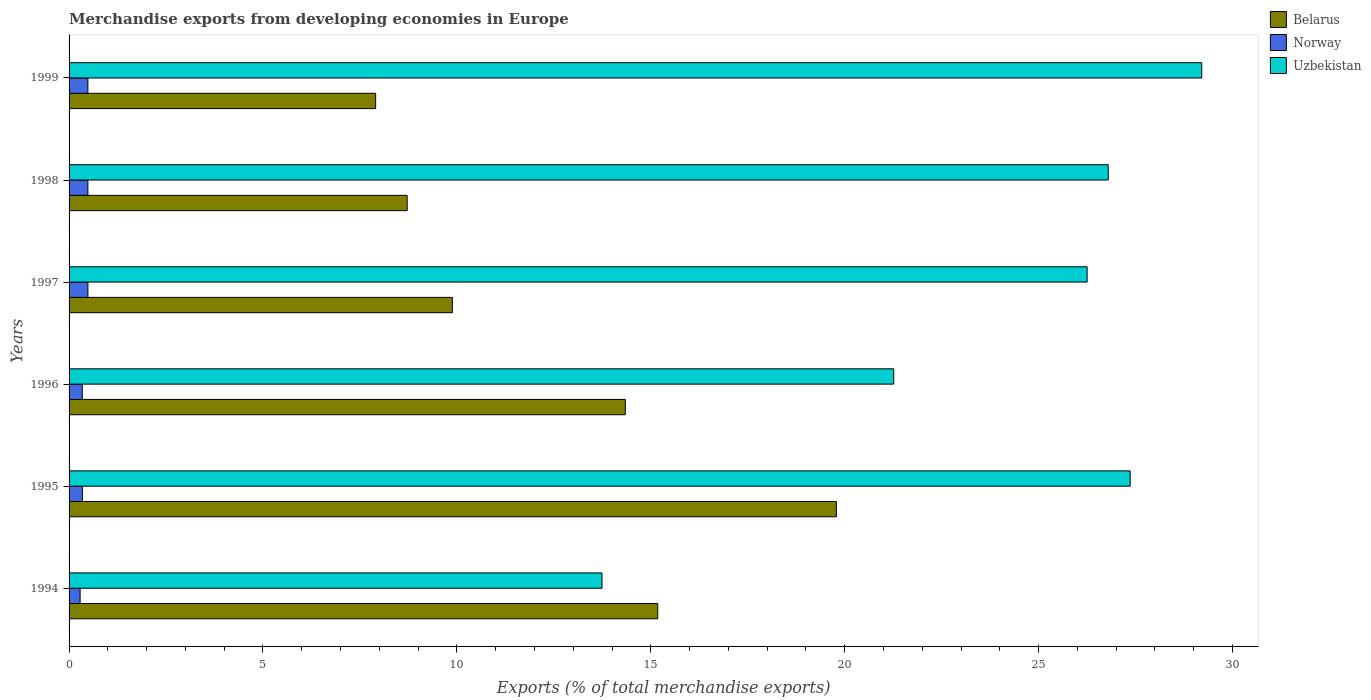How many different coloured bars are there?
Your answer should be compact. 3. How many bars are there on the 2nd tick from the bottom?
Offer a very short reply. 3. What is the label of the 3rd group of bars from the top?
Your response must be concise. 1997. In how many cases, is the number of bars for a given year not equal to the number of legend labels?
Provide a succinct answer. 0. What is the percentage of total merchandise exports in Uzbekistan in 1998?
Ensure brevity in your answer.  26.79. Across all years, what is the maximum percentage of total merchandise exports in Norway?
Keep it short and to the point. 0.49. Across all years, what is the minimum percentage of total merchandise exports in Belarus?
Your answer should be very brief. 7.9. In which year was the percentage of total merchandise exports in Belarus maximum?
Keep it short and to the point. 1995. What is the total percentage of total merchandise exports in Belarus in the graph?
Provide a short and direct response. 75.81. What is the difference between the percentage of total merchandise exports in Uzbekistan in 1996 and that in 1999?
Your answer should be compact. -7.94. What is the difference between the percentage of total merchandise exports in Uzbekistan in 1994 and the percentage of total merchandise exports in Norway in 1997?
Offer a terse response. 13.26. What is the average percentage of total merchandise exports in Belarus per year?
Your answer should be very brief. 12.64. In the year 1999, what is the difference between the percentage of total merchandise exports in Uzbekistan and percentage of total merchandise exports in Norway?
Give a very brief answer. 28.72. What is the ratio of the percentage of total merchandise exports in Norway in 1994 to that in 1998?
Your response must be concise. 0.59. Is the percentage of total merchandise exports in Norway in 1994 less than that in 1999?
Your answer should be compact. Yes. What is the difference between the highest and the second highest percentage of total merchandise exports in Belarus?
Offer a very short reply. 4.61. What is the difference between the highest and the lowest percentage of total merchandise exports in Uzbekistan?
Your answer should be compact. 15.46. In how many years, is the percentage of total merchandise exports in Uzbekistan greater than the average percentage of total merchandise exports in Uzbekistan taken over all years?
Provide a succinct answer. 4. Is the sum of the percentage of total merchandise exports in Uzbekistan in 1994 and 1996 greater than the maximum percentage of total merchandise exports in Belarus across all years?
Your answer should be compact. Yes. What does the 1st bar from the top in 1994 represents?
Your answer should be very brief. Uzbekistan. What does the 1st bar from the bottom in 1996 represents?
Offer a terse response. Belarus. How many years are there in the graph?
Your response must be concise. 6. Where does the legend appear in the graph?
Your answer should be very brief. Top right. How many legend labels are there?
Make the answer very short. 3. How are the legend labels stacked?
Your answer should be very brief. Vertical. What is the title of the graph?
Provide a succinct answer. Merchandise exports from developing economies in Europe. What is the label or title of the X-axis?
Offer a very short reply. Exports (% of total merchandise exports). What is the Exports (% of total merchandise exports) of Belarus in 1994?
Offer a terse response. 15.18. What is the Exports (% of total merchandise exports) of Norway in 1994?
Keep it short and to the point. 0.28. What is the Exports (% of total merchandise exports) of Uzbekistan in 1994?
Offer a terse response. 13.74. What is the Exports (% of total merchandise exports) of Belarus in 1995?
Make the answer very short. 19.78. What is the Exports (% of total merchandise exports) of Norway in 1995?
Your response must be concise. 0.34. What is the Exports (% of total merchandise exports) of Uzbekistan in 1995?
Make the answer very short. 27.36. What is the Exports (% of total merchandise exports) in Belarus in 1996?
Provide a short and direct response. 14.34. What is the Exports (% of total merchandise exports) in Norway in 1996?
Your answer should be very brief. 0.34. What is the Exports (% of total merchandise exports) in Uzbekistan in 1996?
Provide a short and direct response. 21.26. What is the Exports (% of total merchandise exports) of Belarus in 1997?
Offer a very short reply. 9.88. What is the Exports (% of total merchandise exports) of Norway in 1997?
Offer a terse response. 0.49. What is the Exports (% of total merchandise exports) in Uzbekistan in 1997?
Provide a short and direct response. 26.25. What is the Exports (% of total merchandise exports) in Belarus in 1998?
Make the answer very short. 8.72. What is the Exports (% of total merchandise exports) of Norway in 1998?
Provide a short and direct response. 0.49. What is the Exports (% of total merchandise exports) in Uzbekistan in 1998?
Your answer should be very brief. 26.79. What is the Exports (% of total merchandise exports) of Belarus in 1999?
Ensure brevity in your answer.  7.9. What is the Exports (% of total merchandise exports) in Norway in 1999?
Your answer should be compact. 0.48. What is the Exports (% of total merchandise exports) of Uzbekistan in 1999?
Offer a very short reply. 29.21. Across all years, what is the maximum Exports (% of total merchandise exports) in Belarus?
Your answer should be very brief. 19.78. Across all years, what is the maximum Exports (% of total merchandise exports) of Norway?
Offer a very short reply. 0.49. Across all years, what is the maximum Exports (% of total merchandise exports) of Uzbekistan?
Give a very brief answer. 29.21. Across all years, what is the minimum Exports (% of total merchandise exports) in Belarus?
Keep it short and to the point. 7.9. Across all years, what is the minimum Exports (% of total merchandise exports) of Norway?
Ensure brevity in your answer.  0.28. Across all years, what is the minimum Exports (% of total merchandise exports) of Uzbekistan?
Offer a very short reply. 13.74. What is the total Exports (% of total merchandise exports) of Belarus in the graph?
Keep it short and to the point. 75.81. What is the total Exports (% of total merchandise exports) in Norway in the graph?
Your response must be concise. 2.42. What is the total Exports (% of total merchandise exports) in Uzbekistan in the graph?
Provide a short and direct response. 144.62. What is the difference between the Exports (% of total merchandise exports) of Belarus in 1994 and that in 1995?
Offer a terse response. -4.61. What is the difference between the Exports (% of total merchandise exports) in Norway in 1994 and that in 1995?
Make the answer very short. -0.06. What is the difference between the Exports (% of total merchandise exports) in Uzbekistan in 1994 and that in 1995?
Your response must be concise. -13.62. What is the difference between the Exports (% of total merchandise exports) in Belarus in 1994 and that in 1996?
Make the answer very short. 0.84. What is the difference between the Exports (% of total merchandise exports) of Norway in 1994 and that in 1996?
Keep it short and to the point. -0.06. What is the difference between the Exports (% of total merchandise exports) in Uzbekistan in 1994 and that in 1996?
Provide a succinct answer. -7.52. What is the difference between the Exports (% of total merchandise exports) in Belarus in 1994 and that in 1997?
Make the answer very short. 5.29. What is the difference between the Exports (% of total merchandise exports) in Norway in 1994 and that in 1997?
Provide a short and direct response. -0.2. What is the difference between the Exports (% of total merchandise exports) in Uzbekistan in 1994 and that in 1997?
Provide a succinct answer. -12.51. What is the difference between the Exports (% of total merchandise exports) in Belarus in 1994 and that in 1998?
Keep it short and to the point. 6.46. What is the difference between the Exports (% of total merchandise exports) of Norway in 1994 and that in 1998?
Give a very brief answer. -0.2. What is the difference between the Exports (% of total merchandise exports) of Uzbekistan in 1994 and that in 1998?
Provide a short and direct response. -13.05. What is the difference between the Exports (% of total merchandise exports) in Belarus in 1994 and that in 1999?
Ensure brevity in your answer.  7.27. What is the difference between the Exports (% of total merchandise exports) in Norway in 1994 and that in 1999?
Your answer should be very brief. -0.2. What is the difference between the Exports (% of total merchandise exports) of Uzbekistan in 1994 and that in 1999?
Give a very brief answer. -15.46. What is the difference between the Exports (% of total merchandise exports) in Belarus in 1995 and that in 1996?
Make the answer very short. 5.44. What is the difference between the Exports (% of total merchandise exports) in Norway in 1995 and that in 1996?
Your answer should be compact. 0. What is the difference between the Exports (% of total merchandise exports) in Uzbekistan in 1995 and that in 1996?
Keep it short and to the point. 6.1. What is the difference between the Exports (% of total merchandise exports) in Belarus in 1995 and that in 1997?
Your response must be concise. 9.9. What is the difference between the Exports (% of total merchandise exports) of Norway in 1995 and that in 1997?
Make the answer very short. -0.14. What is the difference between the Exports (% of total merchandise exports) of Uzbekistan in 1995 and that in 1997?
Offer a very short reply. 1.11. What is the difference between the Exports (% of total merchandise exports) in Belarus in 1995 and that in 1998?
Give a very brief answer. 11.07. What is the difference between the Exports (% of total merchandise exports) of Norway in 1995 and that in 1998?
Give a very brief answer. -0.14. What is the difference between the Exports (% of total merchandise exports) in Uzbekistan in 1995 and that in 1998?
Offer a very short reply. 0.57. What is the difference between the Exports (% of total merchandise exports) of Belarus in 1995 and that in 1999?
Keep it short and to the point. 11.88. What is the difference between the Exports (% of total merchandise exports) in Norway in 1995 and that in 1999?
Keep it short and to the point. -0.14. What is the difference between the Exports (% of total merchandise exports) of Uzbekistan in 1995 and that in 1999?
Give a very brief answer. -1.85. What is the difference between the Exports (% of total merchandise exports) of Belarus in 1996 and that in 1997?
Your response must be concise. 4.46. What is the difference between the Exports (% of total merchandise exports) of Norway in 1996 and that in 1997?
Ensure brevity in your answer.  -0.15. What is the difference between the Exports (% of total merchandise exports) of Uzbekistan in 1996 and that in 1997?
Offer a terse response. -4.99. What is the difference between the Exports (% of total merchandise exports) in Belarus in 1996 and that in 1998?
Provide a short and direct response. 5.63. What is the difference between the Exports (% of total merchandise exports) in Norway in 1996 and that in 1998?
Provide a succinct answer. -0.14. What is the difference between the Exports (% of total merchandise exports) in Uzbekistan in 1996 and that in 1998?
Offer a terse response. -5.53. What is the difference between the Exports (% of total merchandise exports) in Belarus in 1996 and that in 1999?
Keep it short and to the point. 6.44. What is the difference between the Exports (% of total merchandise exports) of Norway in 1996 and that in 1999?
Your answer should be compact. -0.14. What is the difference between the Exports (% of total merchandise exports) of Uzbekistan in 1996 and that in 1999?
Provide a short and direct response. -7.94. What is the difference between the Exports (% of total merchandise exports) in Belarus in 1997 and that in 1998?
Your answer should be compact. 1.17. What is the difference between the Exports (% of total merchandise exports) of Uzbekistan in 1997 and that in 1998?
Ensure brevity in your answer.  -0.54. What is the difference between the Exports (% of total merchandise exports) in Belarus in 1997 and that in 1999?
Give a very brief answer. 1.98. What is the difference between the Exports (% of total merchandise exports) of Norway in 1997 and that in 1999?
Your answer should be compact. 0. What is the difference between the Exports (% of total merchandise exports) of Uzbekistan in 1997 and that in 1999?
Provide a succinct answer. -2.96. What is the difference between the Exports (% of total merchandise exports) in Belarus in 1998 and that in 1999?
Give a very brief answer. 0.81. What is the difference between the Exports (% of total merchandise exports) of Norway in 1998 and that in 1999?
Keep it short and to the point. 0. What is the difference between the Exports (% of total merchandise exports) of Uzbekistan in 1998 and that in 1999?
Make the answer very short. -2.41. What is the difference between the Exports (% of total merchandise exports) of Belarus in 1994 and the Exports (% of total merchandise exports) of Norway in 1995?
Ensure brevity in your answer.  14.84. What is the difference between the Exports (% of total merchandise exports) in Belarus in 1994 and the Exports (% of total merchandise exports) in Uzbekistan in 1995?
Give a very brief answer. -12.18. What is the difference between the Exports (% of total merchandise exports) in Norway in 1994 and the Exports (% of total merchandise exports) in Uzbekistan in 1995?
Offer a very short reply. -27.08. What is the difference between the Exports (% of total merchandise exports) of Belarus in 1994 and the Exports (% of total merchandise exports) of Norway in 1996?
Your answer should be compact. 14.84. What is the difference between the Exports (% of total merchandise exports) of Belarus in 1994 and the Exports (% of total merchandise exports) of Uzbekistan in 1996?
Your response must be concise. -6.08. What is the difference between the Exports (% of total merchandise exports) in Norway in 1994 and the Exports (% of total merchandise exports) in Uzbekistan in 1996?
Provide a short and direct response. -20.98. What is the difference between the Exports (% of total merchandise exports) of Belarus in 1994 and the Exports (% of total merchandise exports) of Norway in 1997?
Offer a very short reply. 14.69. What is the difference between the Exports (% of total merchandise exports) in Belarus in 1994 and the Exports (% of total merchandise exports) in Uzbekistan in 1997?
Keep it short and to the point. -11.07. What is the difference between the Exports (% of total merchandise exports) of Norway in 1994 and the Exports (% of total merchandise exports) of Uzbekistan in 1997?
Provide a short and direct response. -25.97. What is the difference between the Exports (% of total merchandise exports) of Belarus in 1994 and the Exports (% of total merchandise exports) of Norway in 1998?
Your response must be concise. 14.69. What is the difference between the Exports (% of total merchandise exports) in Belarus in 1994 and the Exports (% of total merchandise exports) in Uzbekistan in 1998?
Give a very brief answer. -11.62. What is the difference between the Exports (% of total merchandise exports) of Norway in 1994 and the Exports (% of total merchandise exports) of Uzbekistan in 1998?
Give a very brief answer. -26.51. What is the difference between the Exports (% of total merchandise exports) in Belarus in 1994 and the Exports (% of total merchandise exports) in Norway in 1999?
Keep it short and to the point. 14.69. What is the difference between the Exports (% of total merchandise exports) in Belarus in 1994 and the Exports (% of total merchandise exports) in Uzbekistan in 1999?
Your answer should be very brief. -14.03. What is the difference between the Exports (% of total merchandise exports) of Norway in 1994 and the Exports (% of total merchandise exports) of Uzbekistan in 1999?
Keep it short and to the point. -28.92. What is the difference between the Exports (% of total merchandise exports) of Belarus in 1995 and the Exports (% of total merchandise exports) of Norway in 1996?
Give a very brief answer. 19.44. What is the difference between the Exports (% of total merchandise exports) of Belarus in 1995 and the Exports (% of total merchandise exports) of Uzbekistan in 1996?
Provide a short and direct response. -1.48. What is the difference between the Exports (% of total merchandise exports) of Norway in 1995 and the Exports (% of total merchandise exports) of Uzbekistan in 1996?
Offer a terse response. -20.92. What is the difference between the Exports (% of total merchandise exports) in Belarus in 1995 and the Exports (% of total merchandise exports) in Norway in 1997?
Your answer should be very brief. 19.3. What is the difference between the Exports (% of total merchandise exports) in Belarus in 1995 and the Exports (% of total merchandise exports) in Uzbekistan in 1997?
Give a very brief answer. -6.47. What is the difference between the Exports (% of total merchandise exports) in Norway in 1995 and the Exports (% of total merchandise exports) in Uzbekistan in 1997?
Ensure brevity in your answer.  -25.91. What is the difference between the Exports (% of total merchandise exports) in Belarus in 1995 and the Exports (% of total merchandise exports) in Norway in 1998?
Keep it short and to the point. 19.3. What is the difference between the Exports (% of total merchandise exports) in Belarus in 1995 and the Exports (% of total merchandise exports) in Uzbekistan in 1998?
Offer a terse response. -7.01. What is the difference between the Exports (% of total merchandise exports) in Norway in 1995 and the Exports (% of total merchandise exports) in Uzbekistan in 1998?
Offer a terse response. -26.45. What is the difference between the Exports (% of total merchandise exports) of Belarus in 1995 and the Exports (% of total merchandise exports) of Norway in 1999?
Make the answer very short. 19.3. What is the difference between the Exports (% of total merchandise exports) of Belarus in 1995 and the Exports (% of total merchandise exports) of Uzbekistan in 1999?
Your answer should be very brief. -9.42. What is the difference between the Exports (% of total merchandise exports) in Norway in 1995 and the Exports (% of total merchandise exports) in Uzbekistan in 1999?
Your answer should be very brief. -28.86. What is the difference between the Exports (% of total merchandise exports) in Belarus in 1996 and the Exports (% of total merchandise exports) in Norway in 1997?
Your answer should be very brief. 13.86. What is the difference between the Exports (% of total merchandise exports) in Belarus in 1996 and the Exports (% of total merchandise exports) in Uzbekistan in 1997?
Make the answer very short. -11.91. What is the difference between the Exports (% of total merchandise exports) of Norway in 1996 and the Exports (% of total merchandise exports) of Uzbekistan in 1997?
Your answer should be very brief. -25.91. What is the difference between the Exports (% of total merchandise exports) in Belarus in 1996 and the Exports (% of total merchandise exports) in Norway in 1998?
Keep it short and to the point. 13.86. What is the difference between the Exports (% of total merchandise exports) in Belarus in 1996 and the Exports (% of total merchandise exports) in Uzbekistan in 1998?
Your answer should be very brief. -12.45. What is the difference between the Exports (% of total merchandise exports) of Norway in 1996 and the Exports (% of total merchandise exports) of Uzbekistan in 1998?
Keep it short and to the point. -26.45. What is the difference between the Exports (% of total merchandise exports) of Belarus in 1996 and the Exports (% of total merchandise exports) of Norway in 1999?
Your response must be concise. 13.86. What is the difference between the Exports (% of total merchandise exports) of Belarus in 1996 and the Exports (% of total merchandise exports) of Uzbekistan in 1999?
Make the answer very short. -14.86. What is the difference between the Exports (% of total merchandise exports) of Norway in 1996 and the Exports (% of total merchandise exports) of Uzbekistan in 1999?
Your response must be concise. -28.87. What is the difference between the Exports (% of total merchandise exports) in Belarus in 1997 and the Exports (% of total merchandise exports) in Norway in 1998?
Ensure brevity in your answer.  9.4. What is the difference between the Exports (% of total merchandise exports) of Belarus in 1997 and the Exports (% of total merchandise exports) of Uzbekistan in 1998?
Provide a short and direct response. -16.91. What is the difference between the Exports (% of total merchandise exports) of Norway in 1997 and the Exports (% of total merchandise exports) of Uzbekistan in 1998?
Give a very brief answer. -26.31. What is the difference between the Exports (% of total merchandise exports) of Belarus in 1997 and the Exports (% of total merchandise exports) of Norway in 1999?
Keep it short and to the point. 9.4. What is the difference between the Exports (% of total merchandise exports) of Belarus in 1997 and the Exports (% of total merchandise exports) of Uzbekistan in 1999?
Your response must be concise. -19.32. What is the difference between the Exports (% of total merchandise exports) of Norway in 1997 and the Exports (% of total merchandise exports) of Uzbekistan in 1999?
Provide a succinct answer. -28.72. What is the difference between the Exports (% of total merchandise exports) in Belarus in 1998 and the Exports (% of total merchandise exports) in Norway in 1999?
Provide a short and direct response. 8.23. What is the difference between the Exports (% of total merchandise exports) of Belarus in 1998 and the Exports (% of total merchandise exports) of Uzbekistan in 1999?
Offer a terse response. -20.49. What is the difference between the Exports (% of total merchandise exports) in Norway in 1998 and the Exports (% of total merchandise exports) in Uzbekistan in 1999?
Offer a terse response. -28.72. What is the average Exports (% of total merchandise exports) of Belarus per year?
Offer a terse response. 12.64. What is the average Exports (% of total merchandise exports) of Norway per year?
Your answer should be compact. 0.4. What is the average Exports (% of total merchandise exports) of Uzbekistan per year?
Give a very brief answer. 24.1. In the year 1994, what is the difference between the Exports (% of total merchandise exports) in Belarus and Exports (% of total merchandise exports) in Norway?
Your answer should be very brief. 14.89. In the year 1994, what is the difference between the Exports (% of total merchandise exports) of Belarus and Exports (% of total merchandise exports) of Uzbekistan?
Offer a terse response. 1.44. In the year 1994, what is the difference between the Exports (% of total merchandise exports) of Norway and Exports (% of total merchandise exports) of Uzbekistan?
Your response must be concise. -13.46. In the year 1995, what is the difference between the Exports (% of total merchandise exports) of Belarus and Exports (% of total merchandise exports) of Norway?
Ensure brevity in your answer.  19.44. In the year 1995, what is the difference between the Exports (% of total merchandise exports) in Belarus and Exports (% of total merchandise exports) in Uzbekistan?
Your answer should be very brief. -7.58. In the year 1995, what is the difference between the Exports (% of total merchandise exports) of Norway and Exports (% of total merchandise exports) of Uzbekistan?
Your answer should be compact. -27.02. In the year 1996, what is the difference between the Exports (% of total merchandise exports) of Belarus and Exports (% of total merchandise exports) of Norway?
Make the answer very short. 14. In the year 1996, what is the difference between the Exports (% of total merchandise exports) in Belarus and Exports (% of total merchandise exports) in Uzbekistan?
Give a very brief answer. -6.92. In the year 1996, what is the difference between the Exports (% of total merchandise exports) of Norway and Exports (% of total merchandise exports) of Uzbekistan?
Make the answer very short. -20.92. In the year 1997, what is the difference between the Exports (% of total merchandise exports) of Belarus and Exports (% of total merchandise exports) of Norway?
Make the answer very short. 9.4. In the year 1997, what is the difference between the Exports (% of total merchandise exports) of Belarus and Exports (% of total merchandise exports) of Uzbekistan?
Provide a succinct answer. -16.37. In the year 1997, what is the difference between the Exports (% of total merchandise exports) of Norway and Exports (% of total merchandise exports) of Uzbekistan?
Offer a very short reply. -25.76. In the year 1998, what is the difference between the Exports (% of total merchandise exports) of Belarus and Exports (% of total merchandise exports) of Norway?
Ensure brevity in your answer.  8.23. In the year 1998, what is the difference between the Exports (% of total merchandise exports) of Belarus and Exports (% of total merchandise exports) of Uzbekistan?
Make the answer very short. -18.08. In the year 1998, what is the difference between the Exports (% of total merchandise exports) of Norway and Exports (% of total merchandise exports) of Uzbekistan?
Your answer should be compact. -26.31. In the year 1999, what is the difference between the Exports (% of total merchandise exports) in Belarus and Exports (% of total merchandise exports) in Norway?
Offer a terse response. 7.42. In the year 1999, what is the difference between the Exports (% of total merchandise exports) in Belarus and Exports (% of total merchandise exports) in Uzbekistan?
Keep it short and to the point. -21.3. In the year 1999, what is the difference between the Exports (% of total merchandise exports) of Norway and Exports (% of total merchandise exports) of Uzbekistan?
Offer a very short reply. -28.72. What is the ratio of the Exports (% of total merchandise exports) of Belarus in 1994 to that in 1995?
Offer a terse response. 0.77. What is the ratio of the Exports (% of total merchandise exports) of Norway in 1994 to that in 1995?
Your answer should be very brief. 0.83. What is the ratio of the Exports (% of total merchandise exports) of Uzbekistan in 1994 to that in 1995?
Your answer should be very brief. 0.5. What is the ratio of the Exports (% of total merchandise exports) of Belarus in 1994 to that in 1996?
Give a very brief answer. 1.06. What is the ratio of the Exports (% of total merchandise exports) of Norway in 1994 to that in 1996?
Provide a succinct answer. 0.84. What is the ratio of the Exports (% of total merchandise exports) in Uzbekistan in 1994 to that in 1996?
Provide a succinct answer. 0.65. What is the ratio of the Exports (% of total merchandise exports) in Belarus in 1994 to that in 1997?
Your response must be concise. 1.54. What is the ratio of the Exports (% of total merchandise exports) in Norway in 1994 to that in 1997?
Make the answer very short. 0.59. What is the ratio of the Exports (% of total merchandise exports) of Uzbekistan in 1994 to that in 1997?
Make the answer very short. 0.52. What is the ratio of the Exports (% of total merchandise exports) in Belarus in 1994 to that in 1998?
Give a very brief answer. 1.74. What is the ratio of the Exports (% of total merchandise exports) in Norway in 1994 to that in 1998?
Offer a terse response. 0.59. What is the ratio of the Exports (% of total merchandise exports) in Uzbekistan in 1994 to that in 1998?
Make the answer very short. 0.51. What is the ratio of the Exports (% of total merchandise exports) in Belarus in 1994 to that in 1999?
Ensure brevity in your answer.  1.92. What is the ratio of the Exports (% of total merchandise exports) of Norway in 1994 to that in 1999?
Provide a short and direct response. 0.59. What is the ratio of the Exports (% of total merchandise exports) in Uzbekistan in 1994 to that in 1999?
Offer a terse response. 0.47. What is the ratio of the Exports (% of total merchandise exports) in Belarus in 1995 to that in 1996?
Offer a very short reply. 1.38. What is the ratio of the Exports (% of total merchandise exports) of Norway in 1995 to that in 1996?
Ensure brevity in your answer.  1.01. What is the ratio of the Exports (% of total merchandise exports) of Uzbekistan in 1995 to that in 1996?
Your answer should be compact. 1.29. What is the ratio of the Exports (% of total merchandise exports) of Belarus in 1995 to that in 1997?
Provide a short and direct response. 2. What is the ratio of the Exports (% of total merchandise exports) in Norway in 1995 to that in 1997?
Offer a very short reply. 0.71. What is the ratio of the Exports (% of total merchandise exports) of Uzbekistan in 1995 to that in 1997?
Your response must be concise. 1.04. What is the ratio of the Exports (% of total merchandise exports) in Belarus in 1995 to that in 1998?
Give a very brief answer. 2.27. What is the ratio of the Exports (% of total merchandise exports) of Norway in 1995 to that in 1998?
Your answer should be compact. 0.71. What is the ratio of the Exports (% of total merchandise exports) of Uzbekistan in 1995 to that in 1998?
Provide a succinct answer. 1.02. What is the ratio of the Exports (% of total merchandise exports) of Belarus in 1995 to that in 1999?
Provide a short and direct response. 2.5. What is the ratio of the Exports (% of total merchandise exports) in Norway in 1995 to that in 1999?
Give a very brief answer. 0.71. What is the ratio of the Exports (% of total merchandise exports) of Uzbekistan in 1995 to that in 1999?
Give a very brief answer. 0.94. What is the ratio of the Exports (% of total merchandise exports) of Belarus in 1996 to that in 1997?
Ensure brevity in your answer.  1.45. What is the ratio of the Exports (% of total merchandise exports) of Norway in 1996 to that in 1997?
Your answer should be compact. 0.7. What is the ratio of the Exports (% of total merchandise exports) in Uzbekistan in 1996 to that in 1997?
Keep it short and to the point. 0.81. What is the ratio of the Exports (% of total merchandise exports) in Belarus in 1996 to that in 1998?
Your answer should be compact. 1.65. What is the ratio of the Exports (% of total merchandise exports) in Norway in 1996 to that in 1998?
Keep it short and to the point. 0.7. What is the ratio of the Exports (% of total merchandise exports) of Uzbekistan in 1996 to that in 1998?
Offer a very short reply. 0.79. What is the ratio of the Exports (% of total merchandise exports) of Belarus in 1996 to that in 1999?
Ensure brevity in your answer.  1.81. What is the ratio of the Exports (% of total merchandise exports) in Norway in 1996 to that in 1999?
Ensure brevity in your answer.  0.7. What is the ratio of the Exports (% of total merchandise exports) of Uzbekistan in 1996 to that in 1999?
Give a very brief answer. 0.73. What is the ratio of the Exports (% of total merchandise exports) in Belarus in 1997 to that in 1998?
Your answer should be compact. 1.13. What is the ratio of the Exports (% of total merchandise exports) of Norway in 1997 to that in 1998?
Give a very brief answer. 1. What is the ratio of the Exports (% of total merchandise exports) in Uzbekistan in 1997 to that in 1998?
Offer a very short reply. 0.98. What is the ratio of the Exports (% of total merchandise exports) in Belarus in 1997 to that in 1999?
Offer a very short reply. 1.25. What is the ratio of the Exports (% of total merchandise exports) of Norway in 1997 to that in 1999?
Your answer should be very brief. 1. What is the ratio of the Exports (% of total merchandise exports) in Uzbekistan in 1997 to that in 1999?
Provide a short and direct response. 0.9. What is the ratio of the Exports (% of total merchandise exports) of Belarus in 1998 to that in 1999?
Keep it short and to the point. 1.1. What is the ratio of the Exports (% of total merchandise exports) in Uzbekistan in 1998 to that in 1999?
Your answer should be very brief. 0.92. What is the difference between the highest and the second highest Exports (% of total merchandise exports) of Belarus?
Give a very brief answer. 4.61. What is the difference between the highest and the second highest Exports (% of total merchandise exports) in Uzbekistan?
Your response must be concise. 1.85. What is the difference between the highest and the lowest Exports (% of total merchandise exports) of Belarus?
Your answer should be very brief. 11.88. What is the difference between the highest and the lowest Exports (% of total merchandise exports) of Norway?
Make the answer very short. 0.2. What is the difference between the highest and the lowest Exports (% of total merchandise exports) in Uzbekistan?
Provide a short and direct response. 15.46. 